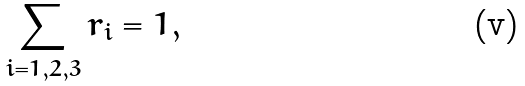Convert formula to latex. <formula><loc_0><loc_0><loc_500><loc_500>\sum _ { i = 1 , 2 , 3 } r _ { i } = 1 ,</formula> 